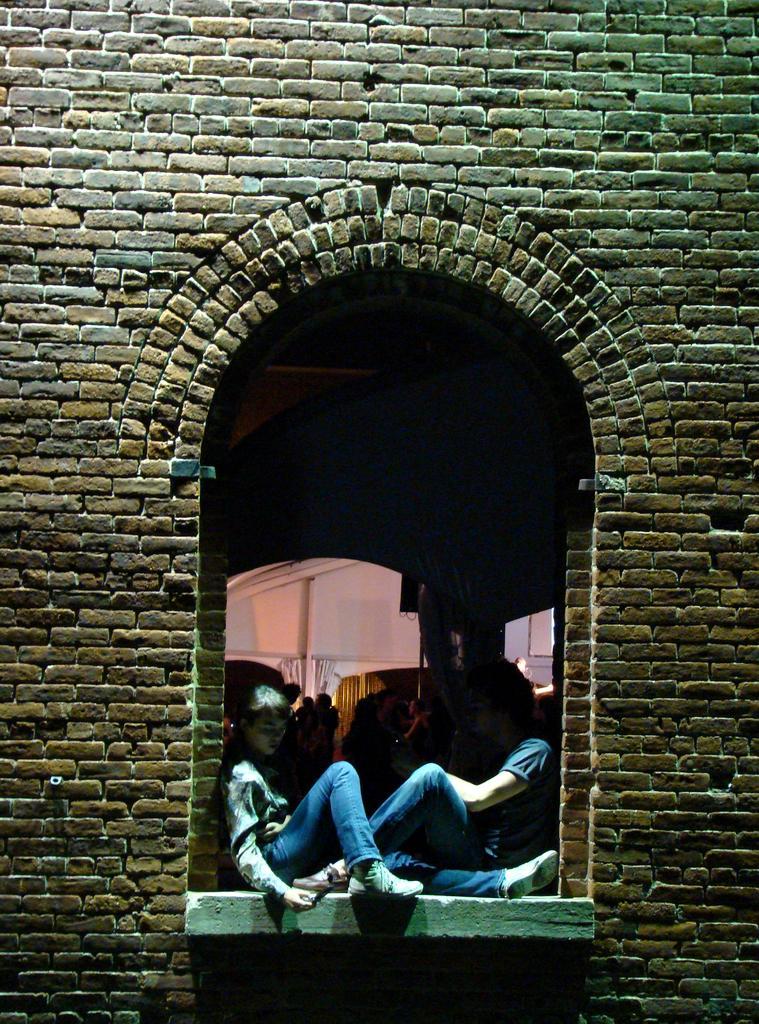In one or two sentences, can you explain what this image depicts? In this image there are some people sitting, and in the background some of them are standing and some objects and in the foreground there is wall. 